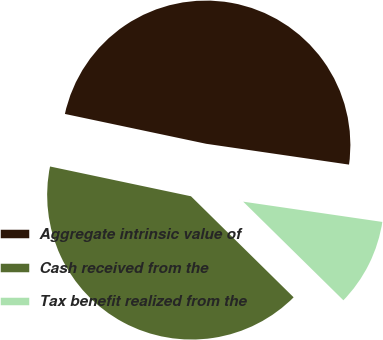<chart> <loc_0><loc_0><loc_500><loc_500><pie_chart><fcel>Aggregate intrinsic value of<fcel>Cash received from the<fcel>Tax benefit realized from the<nl><fcel>48.99%<fcel>40.94%<fcel>10.07%<nl></chart> 